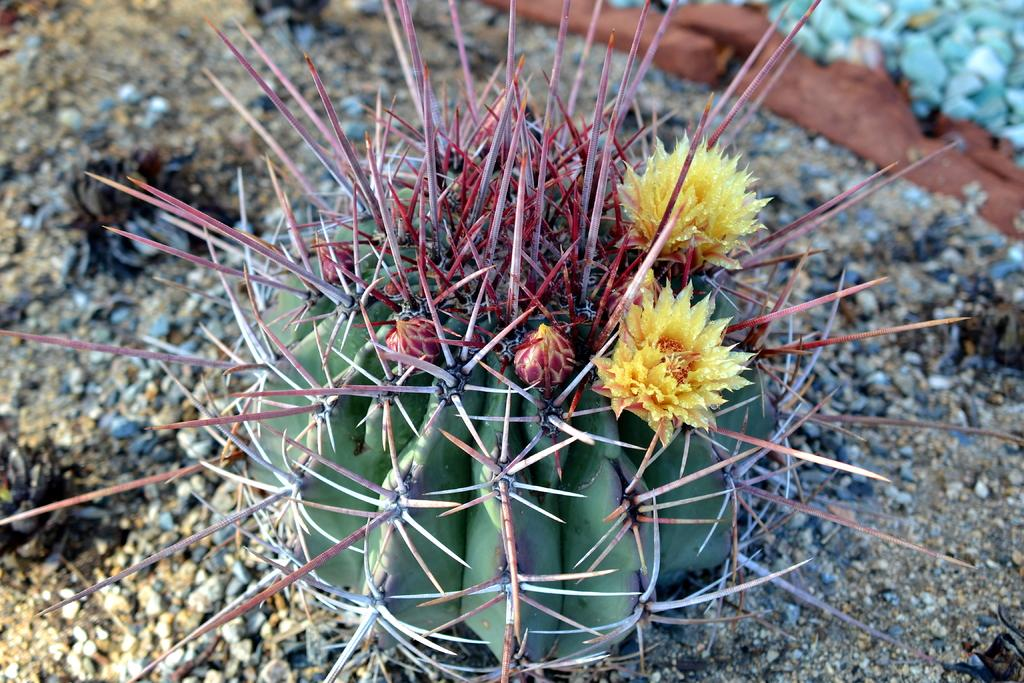What type of living organism is present in the image? There is a plant in the image. What type of inanimate objects can be seen in the image? There are stones and sand visible in the image. What type of shade is provided by the plant in the image? The image does not provide information about the type of shade provided by the plant. Can you hear any thunder in the image? The image is silent and does not depict any audible elements, such as thunder. 